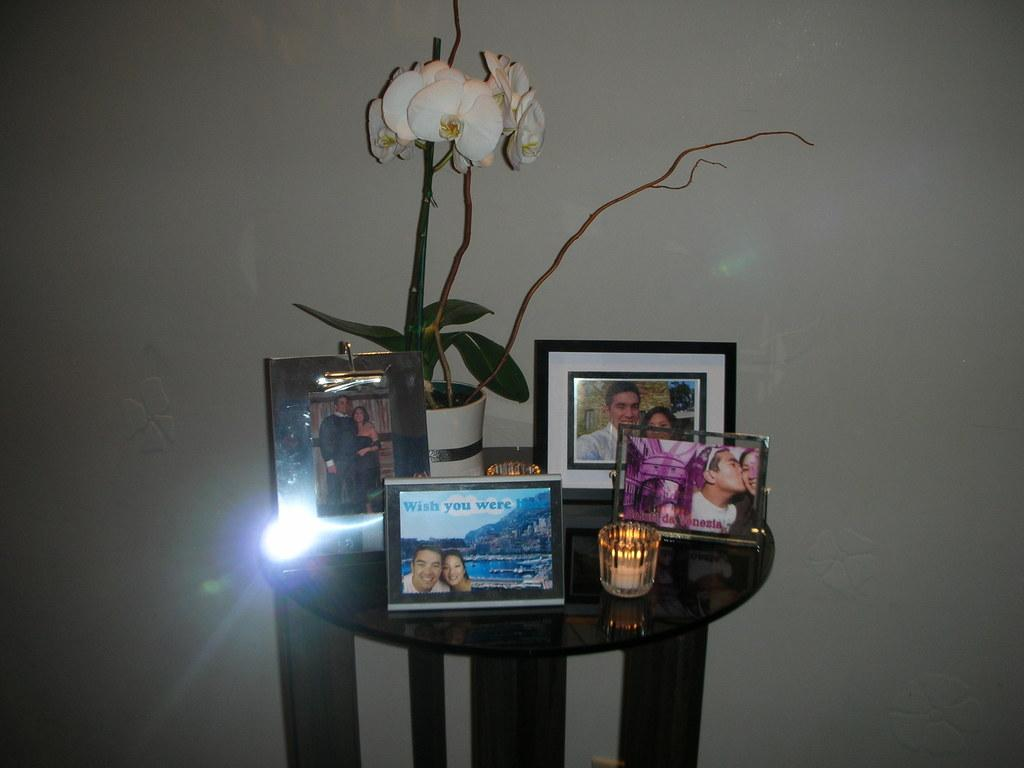<image>
Render a clear and concise summary of the photo. A table with an orchid on it and a lot of framed pictures with one that says 'wish you were here". 